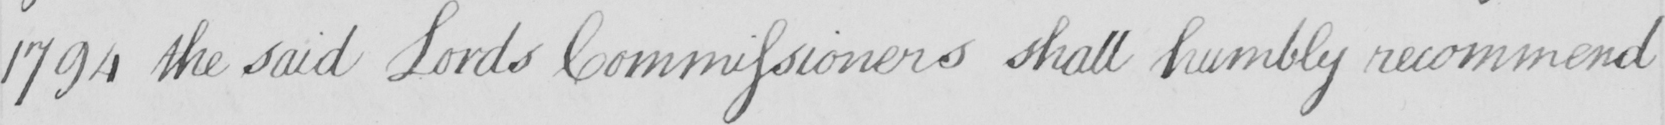Can you read and transcribe this handwriting? 1794 the said Lords Commissioners shall humbly recommend 